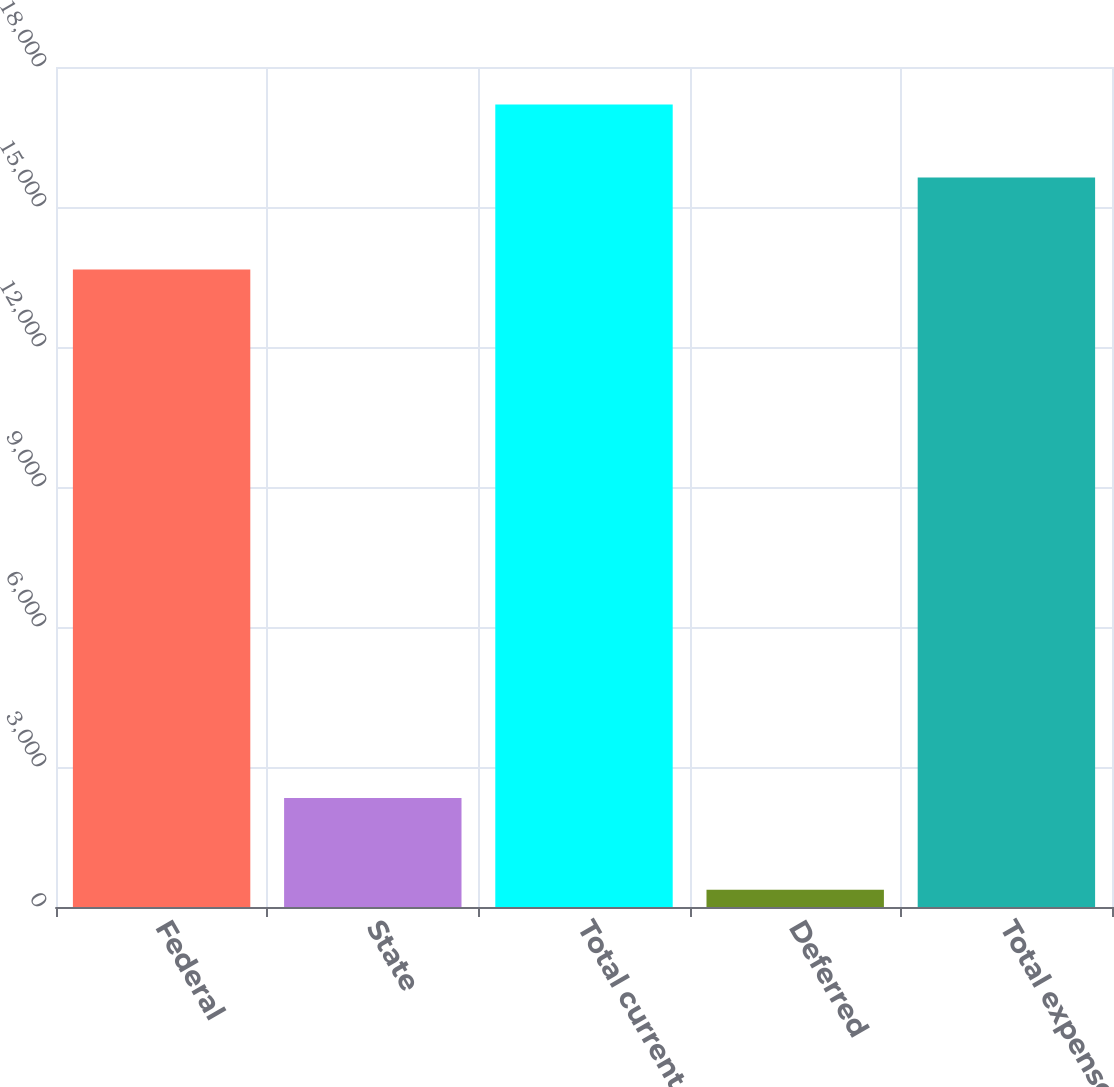<chart> <loc_0><loc_0><loc_500><loc_500><bar_chart><fcel>Federal<fcel>State<fcel>Total current<fcel>Deferred<fcel>Total expense<nl><fcel>13661<fcel>2338<fcel>17194.1<fcel>368<fcel>15631<nl></chart> 